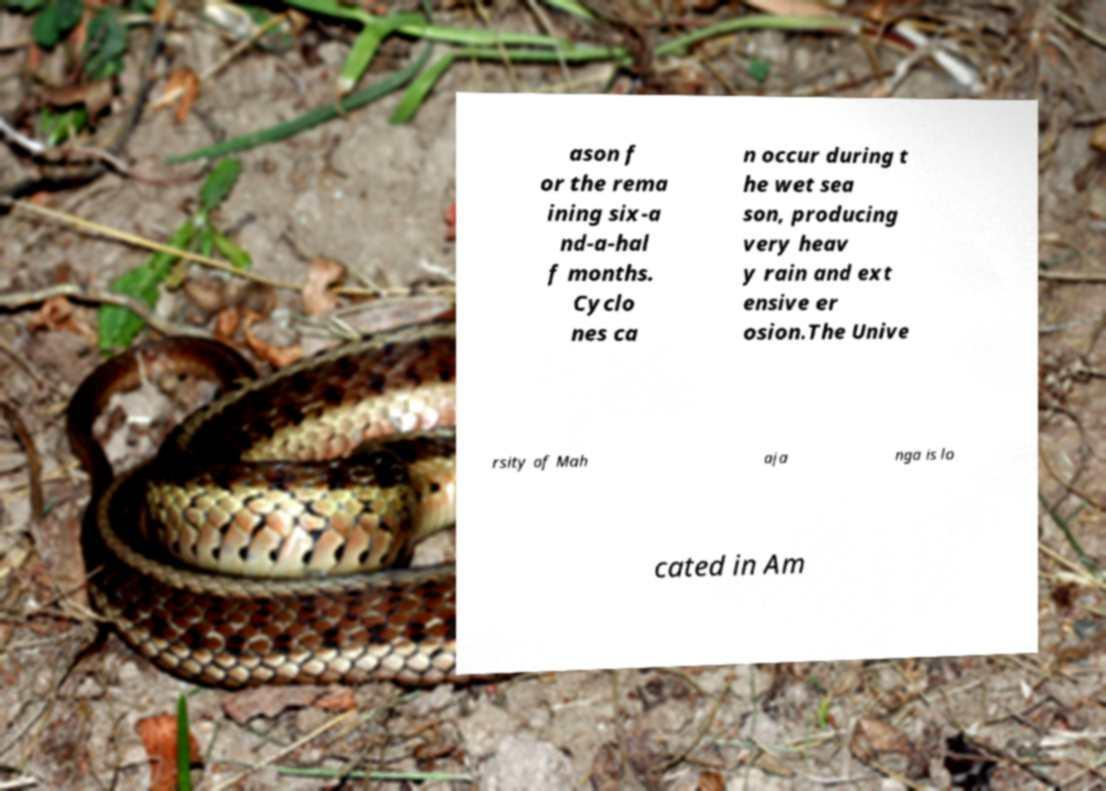Could you assist in decoding the text presented in this image and type it out clearly? ason f or the rema ining six-a nd-a-hal f months. Cyclo nes ca n occur during t he wet sea son, producing very heav y rain and ext ensive er osion.The Unive rsity of Mah aja nga is lo cated in Am 